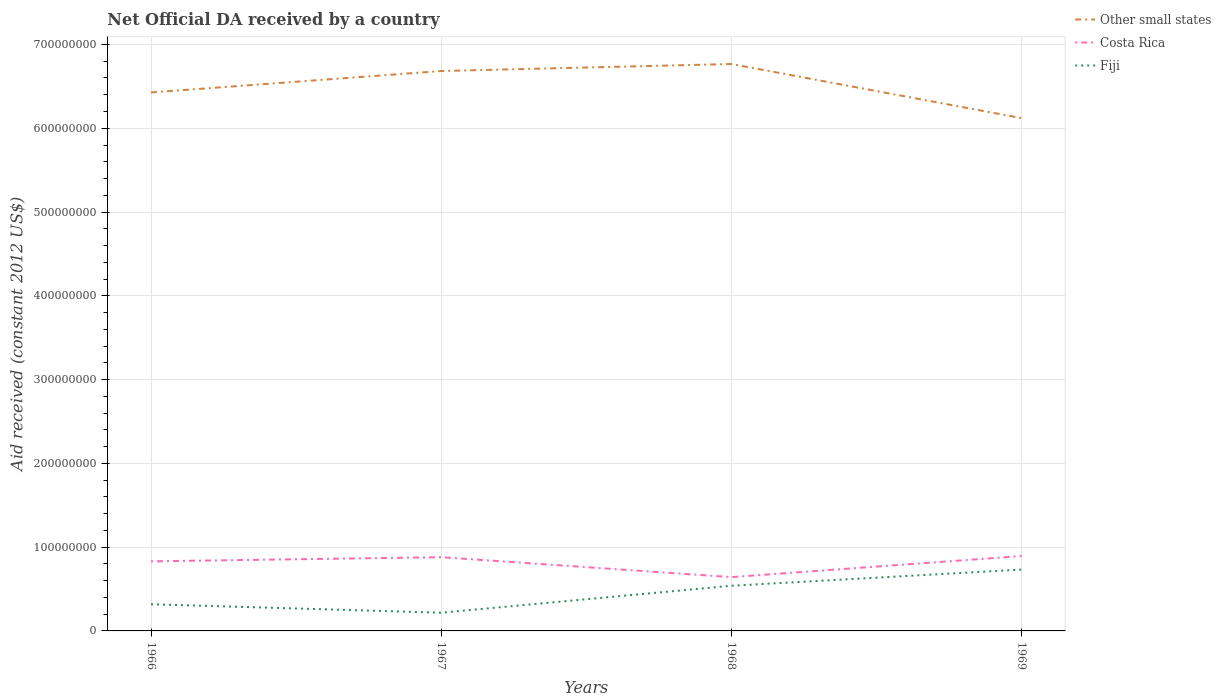Across all years, what is the maximum net official development assistance aid received in Other small states?
Ensure brevity in your answer.  6.12e+08. In which year was the net official development assistance aid received in Costa Rica maximum?
Give a very brief answer. 1968. What is the total net official development assistance aid received in Fiji in the graph?
Offer a terse response. -4.14e+07. What is the difference between the highest and the second highest net official development assistance aid received in Costa Rica?
Your response must be concise. 2.52e+07. What is the difference between two consecutive major ticks on the Y-axis?
Your response must be concise. 1.00e+08. Are the values on the major ticks of Y-axis written in scientific E-notation?
Provide a short and direct response. No. Does the graph contain grids?
Make the answer very short. Yes. Where does the legend appear in the graph?
Provide a short and direct response. Top right. How many legend labels are there?
Keep it short and to the point. 3. What is the title of the graph?
Make the answer very short. Net Official DA received by a country. What is the label or title of the Y-axis?
Provide a succinct answer. Aid received (constant 2012 US$). What is the Aid received (constant 2012 US$) of Other small states in 1966?
Make the answer very short. 6.43e+08. What is the Aid received (constant 2012 US$) of Costa Rica in 1966?
Make the answer very short. 8.30e+07. What is the Aid received (constant 2012 US$) in Fiji in 1966?
Provide a short and direct response. 3.18e+07. What is the Aid received (constant 2012 US$) in Other small states in 1967?
Offer a very short reply. 6.68e+08. What is the Aid received (constant 2012 US$) of Costa Rica in 1967?
Ensure brevity in your answer.  8.80e+07. What is the Aid received (constant 2012 US$) of Fiji in 1967?
Your response must be concise. 2.17e+07. What is the Aid received (constant 2012 US$) in Other small states in 1968?
Your answer should be very brief. 6.77e+08. What is the Aid received (constant 2012 US$) in Costa Rica in 1968?
Provide a succinct answer. 6.42e+07. What is the Aid received (constant 2012 US$) in Fiji in 1968?
Give a very brief answer. 5.39e+07. What is the Aid received (constant 2012 US$) of Other small states in 1969?
Make the answer very short. 6.12e+08. What is the Aid received (constant 2012 US$) in Costa Rica in 1969?
Offer a very short reply. 8.94e+07. What is the Aid received (constant 2012 US$) in Fiji in 1969?
Offer a terse response. 7.32e+07. Across all years, what is the maximum Aid received (constant 2012 US$) of Other small states?
Your answer should be very brief. 6.77e+08. Across all years, what is the maximum Aid received (constant 2012 US$) of Costa Rica?
Your answer should be compact. 8.94e+07. Across all years, what is the maximum Aid received (constant 2012 US$) of Fiji?
Offer a terse response. 7.32e+07. Across all years, what is the minimum Aid received (constant 2012 US$) in Other small states?
Give a very brief answer. 6.12e+08. Across all years, what is the minimum Aid received (constant 2012 US$) of Costa Rica?
Provide a short and direct response. 6.42e+07. Across all years, what is the minimum Aid received (constant 2012 US$) of Fiji?
Keep it short and to the point. 2.17e+07. What is the total Aid received (constant 2012 US$) in Other small states in the graph?
Keep it short and to the point. 2.60e+09. What is the total Aid received (constant 2012 US$) of Costa Rica in the graph?
Offer a terse response. 3.25e+08. What is the total Aid received (constant 2012 US$) of Fiji in the graph?
Give a very brief answer. 1.81e+08. What is the difference between the Aid received (constant 2012 US$) in Other small states in 1966 and that in 1967?
Your answer should be very brief. -2.56e+07. What is the difference between the Aid received (constant 2012 US$) of Costa Rica in 1966 and that in 1967?
Keep it short and to the point. -4.98e+06. What is the difference between the Aid received (constant 2012 US$) of Fiji in 1966 and that in 1967?
Provide a succinct answer. 1.01e+07. What is the difference between the Aid received (constant 2012 US$) of Other small states in 1966 and that in 1968?
Offer a terse response. -3.40e+07. What is the difference between the Aid received (constant 2012 US$) of Costa Rica in 1966 and that in 1968?
Your response must be concise. 1.88e+07. What is the difference between the Aid received (constant 2012 US$) in Fiji in 1966 and that in 1968?
Make the answer very short. -2.21e+07. What is the difference between the Aid received (constant 2012 US$) in Other small states in 1966 and that in 1969?
Your response must be concise. 3.06e+07. What is the difference between the Aid received (constant 2012 US$) of Costa Rica in 1966 and that in 1969?
Make the answer very short. -6.35e+06. What is the difference between the Aid received (constant 2012 US$) of Fiji in 1966 and that in 1969?
Your answer should be compact. -4.14e+07. What is the difference between the Aid received (constant 2012 US$) in Other small states in 1967 and that in 1968?
Give a very brief answer. -8.37e+06. What is the difference between the Aid received (constant 2012 US$) of Costa Rica in 1967 and that in 1968?
Provide a succinct answer. 2.38e+07. What is the difference between the Aid received (constant 2012 US$) of Fiji in 1967 and that in 1968?
Offer a terse response. -3.22e+07. What is the difference between the Aid received (constant 2012 US$) in Other small states in 1967 and that in 1969?
Give a very brief answer. 5.62e+07. What is the difference between the Aid received (constant 2012 US$) in Costa Rica in 1967 and that in 1969?
Provide a succinct answer. -1.37e+06. What is the difference between the Aid received (constant 2012 US$) in Fiji in 1967 and that in 1969?
Ensure brevity in your answer.  -5.15e+07. What is the difference between the Aid received (constant 2012 US$) of Other small states in 1968 and that in 1969?
Your answer should be very brief. 6.46e+07. What is the difference between the Aid received (constant 2012 US$) in Costa Rica in 1968 and that in 1969?
Your response must be concise. -2.52e+07. What is the difference between the Aid received (constant 2012 US$) in Fiji in 1968 and that in 1969?
Keep it short and to the point. -1.93e+07. What is the difference between the Aid received (constant 2012 US$) in Other small states in 1966 and the Aid received (constant 2012 US$) in Costa Rica in 1967?
Offer a terse response. 5.55e+08. What is the difference between the Aid received (constant 2012 US$) of Other small states in 1966 and the Aid received (constant 2012 US$) of Fiji in 1967?
Your response must be concise. 6.21e+08. What is the difference between the Aid received (constant 2012 US$) in Costa Rica in 1966 and the Aid received (constant 2012 US$) in Fiji in 1967?
Your answer should be very brief. 6.13e+07. What is the difference between the Aid received (constant 2012 US$) of Other small states in 1966 and the Aid received (constant 2012 US$) of Costa Rica in 1968?
Your response must be concise. 5.78e+08. What is the difference between the Aid received (constant 2012 US$) in Other small states in 1966 and the Aid received (constant 2012 US$) in Fiji in 1968?
Give a very brief answer. 5.89e+08. What is the difference between the Aid received (constant 2012 US$) in Costa Rica in 1966 and the Aid received (constant 2012 US$) in Fiji in 1968?
Ensure brevity in your answer.  2.91e+07. What is the difference between the Aid received (constant 2012 US$) in Other small states in 1966 and the Aid received (constant 2012 US$) in Costa Rica in 1969?
Give a very brief answer. 5.53e+08. What is the difference between the Aid received (constant 2012 US$) in Other small states in 1966 and the Aid received (constant 2012 US$) in Fiji in 1969?
Make the answer very short. 5.69e+08. What is the difference between the Aid received (constant 2012 US$) of Costa Rica in 1966 and the Aid received (constant 2012 US$) of Fiji in 1969?
Your response must be concise. 9.81e+06. What is the difference between the Aid received (constant 2012 US$) of Other small states in 1967 and the Aid received (constant 2012 US$) of Costa Rica in 1968?
Provide a short and direct response. 6.04e+08. What is the difference between the Aid received (constant 2012 US$) of Other small states in 1967 and the Aid received (constant 2012 US$) of Fiji in 1968?
Ensure brevity in your answer.  6.14e+08. What is the difference between the Aid received (constant 2012 US$) in Costa Rica in 1967 and the Aid received (constant 2012 US$) in Fiji in 1968?
Provide a short and direct response. 3.41e+07. What is the difference between the Aid received (constant 2012 US$) of Other small states in 1967 and the Aid received (constant 2012 US$) of Costa Rica in 1969?
Keep it short and to the point. 5.79e+08. What is the difference between the Aid received (constant 2012 US$) of Other small states in 1967 and the Aid received (constant 2012 US$) of Fiji in 1969?
Provide a succinct answer. 5.95e+08. What is the difference between the Aid received (constant 2012 US$) of Costa Rica in 1967 and the Aid received (constant 2012 US$) of Fiji in 1969?
Provide a short and direct response. 1.48e+07. What is the difference between the Aid received (constant 2012 US$) of Other small states in 1968 and the Aid received (constant 2012 US$) of Costa Rica in 1969?
Offer a very short reply. 5.87e+08. What is the difference between the Aid received (constant 2012 US$) of Other small states in 1968 and the Aid received (constant 2012 US$) of Fiji in 1969?
Give a very brief answer. 6.03e+08. What is the difference between the Aid received (constant 2012 US$) in Costa Rica in 1968 and the Aid received (constant 2012 US$) in Fiji in 1969?
Keep it short and to the point. -9.02e+06. What is the average Aid received (constant 2012 US$) in Other small states per year?
Provide a succinct answer. 6.50e+08. What is the average Aid received (constant 2012 US$) of Costa Rica per year?
Keep it short and to the point. 8.12e+07. What is the average Aid received (constant 2012 US$) in Fiji per year?
Your answer should be compact. 4.52e+07. In the year 1966, what is the difference between the Aid received (constant 2012 US$) in Other small states and Aid received (constant 2012 US$) in Costa Rica?
Give a very brief answer. 5.60e+08. In the year 1966, what is the difference between the Aid received (constant 2012 US$) in Other small states and Aid received (constant 2012 US$) in Fiji?
Offer a terse response. 6.11e+08. In the year 1966, what is the difference between the Aid received (constant 2012 US$) of Costa Rica and Aid received (constant 2012 US$) of Fiji?
Give a very brief answer. 5.12e+07. In the year 1967, what is the difference between the Aid received (constant 2012 US$) of Other small states and Aid received (constant 2012 US$) of Costa Rica?
Give a very brief answer. 5.80e+08. In the year 1967, what is the difference between the Aid received (constant 2012 US$) of Other small states and Aid received (constant 2012 US$) of Fiji?
Give a very brief answer. 6.47e+08. In the year 1967, what is the difference between the Aid received (constant 2012 US$) of Costa Rica and Aid received (constant 2012 US$) of Fiji?
Offer a very short reply. 6.63e+07. In the year 1968, what is the difference between the Aid received (constant 2012 US$) in Other small states and Aid received (constant 2012 US$) in Costa Rica?
Your answer should be very brief. 6.12e+08. In the year 1968, what is the difference between the Aid received (constant 2012 US$) of Other small states and Aid received (constant 2012 US$) of Fiji?
Offer a terse response. 6.23e+08. In the year 1968, what is the difference between the Aid received (constant 2012 US$) in Costa Rica and Aid received (constant 2012 US$) in Fiji?
Keep it short and to the point. 1.03e+07. In the year 1969, what is the difference between the Aid received (constant 2012 US$) in Other small states and Aid received (constant 2012 US$) in Costa Rica?
Your answer should be compact. 5.23e+08. In the year 1969, what is the difference between the Aid received (constant 2012 US$) in Other small states and Aid received (constant 2012 US$) in Fiji?
Your response must be concise. 5.39e+08. In the year 1969, what is the difference between the Aid received (constant 2012 US$) of Costa Rica and Aid received (constant 2012 US$) of Fiji?
Your response must be concise. 1.62e+07. What is the ratio of the Aid received (constant 2012 US$) of Other small states in 1966 to that in 1967?
Offer a very short reply. 0.96. What is the ratio of the Aid received (constant 2012 US$) of Costa Rica in 1966 to that in 1967?
Make the answer very short. 0.94. What is the ratio of the Aid received (constant 2012 US$) in Fiji in 1966 to that in 1967?
Offer a very short reply. 1.47. What is the ratio of the Aid received (constant 2012 US$) in Other small states in 1966 to that in 1968?
Provide a succinct answer. 0.95. What is the ratio of the Aid received (constant 2012 US$) in Costa Rica in 1966 to that in 1968?
Your response must be concise. 1.29. What is the ratio of the Aid received (constant 2012 US$) of Fiji in 1966 to that in 1968?
Provide a short and direct response. 0.59. What is the ratio of the Aid received (constant 2012 US$) in Other small states in 1966 to that in 1969?
Offer a terse response. 1.05. What is the ratio of the Aid received (constant 2012 US$) in Costa Rica in 1966 to that in 1969?
Offer a very short reply. 0.93. What is the ratio of the Aid received (constant 2012 US$) in Fiji in 1966 to that in 1969?
Offer a very short reply. 0.43. What is the ratio of the Aid received (constant 2012 US$) of Other small states in 1967 to that in 1968?
Ensure brevity in your answer.  0.99. What is the ratio of the Aid received (constant 2012 US$) in Costa Rica in 1967 to that in 1968?
Your answer should be very brief. 1.37. What is the ratio of the Aid received (constant 2012 US$) in Fiji in 1967 to that in 1968?
Make the answer very short. 0.4. What is the ratio of the Aid received (constant 2012 US$) in Other small states in 1967 to that in 1969?
Your answer should be compact. 1.09. What is the ratio of the Aid received (constant 2012 US$) in Costa Rica in 1967 to that in 1969?
Make the answer very short. 0.98. What is the ratio of the Aid received (constant 2012 US$) in Fiji in 1967 to that in 1969?
Provide a short and direct response. 0.3. What is the ratio of the Aid received (constant 2012 US$) in Other small states in 1968 to that in 1969?
Your response must be concise. 1.11. What is the ratio of the Aid received (constant 2012 US$) of Costa Rica in 1968 to that in 1969?
Your response must be concise. 0.72. What is the ratio of the Aid received (constant 2012 US$) of Fiji in 1968 to that in 1969?
Your answer should be compact. 0.74. What is the difference between the highest and the second highest Aid received (constant 2012 US$) in Other small states?
Give a very brief answer. 8.37e+06. What is the difference between the highest and the second highest Aid received (constant 2012 US$) in Costa Rica?
Give a very brief answer. 1.37e+06. What is the difference between the highest and the second highest Aid received (constant 2012 US$) in Fiji?
Provide a succinct answer. 1.93e+07. What is the difference between the highest and the lowest Aid received (constant 2012 US$) of Other small states?
Your answer should be very brief. 6.46e+07. What is the difference between the highest and the lowest Aid received (constant 2012 US$) in Costa Rica?
Your answer should be compact. 2.52e+07. What is the difference between the highest and the lowest Aid received (constant 2012 US$) in Fiji?
Make the answer very short. 5.15e+07. 